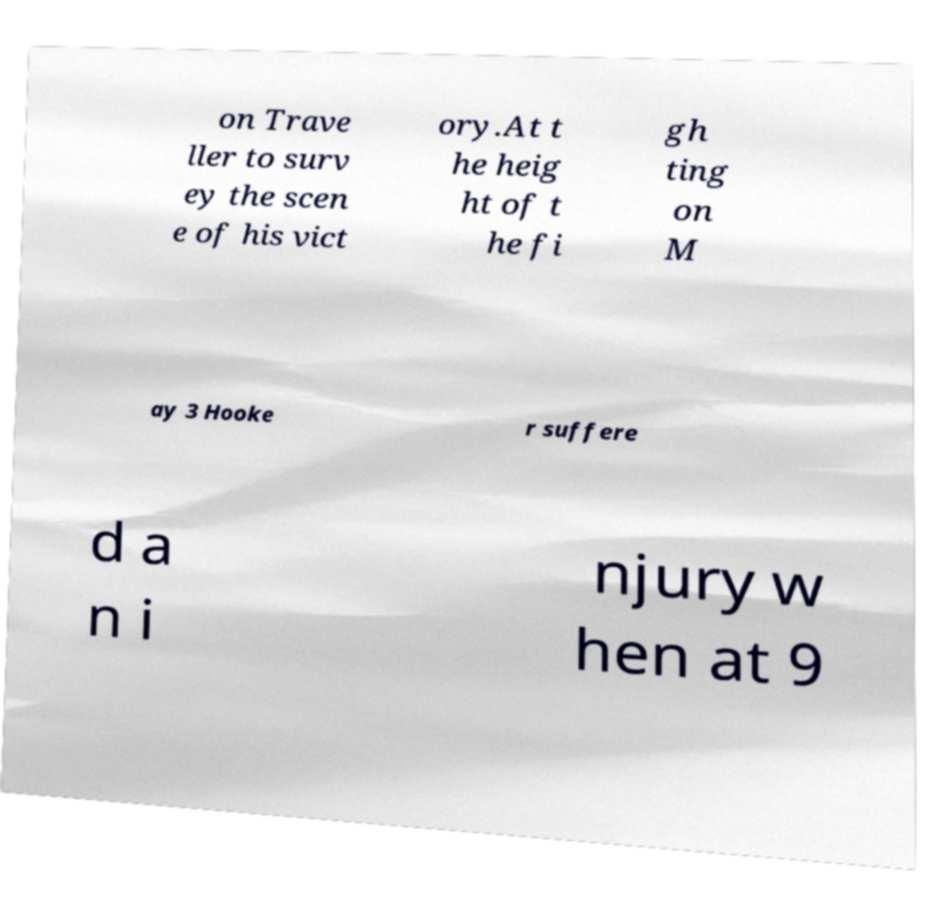Can you read and provide the text displayed in the image?This photo seems to have some interesting text. Can you extract and type it out for me? on Trave ller to surv ey the scen e of his vict ory.At t he heig ht of t he fi gh ting on M ay 3 Hooke r suffere d a n i njury w hen at 9 